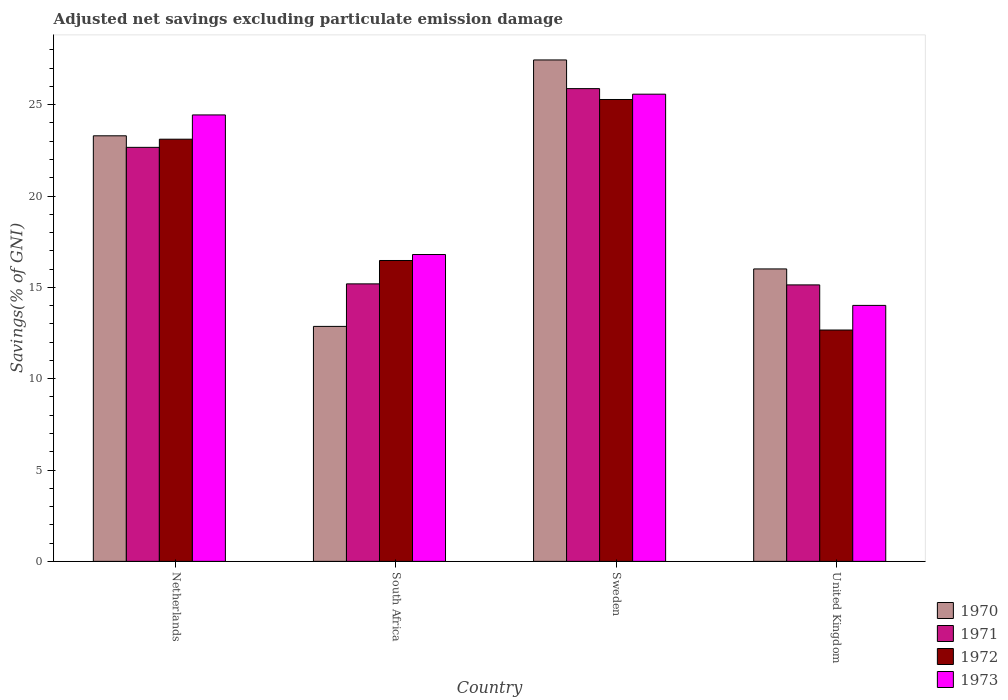How many different coloured bars are there?
Your answer should be very brief. 4. How many groups of bars are there?
Your response must be concise. 4. Are the number of bars on each tick of the X-axis equal?
Give a very brief answer. Yes. How many bars are there on the 4th tick from the right?
Make the answer very short. 4. What is the label of the 3rd group of bars from the left?
Your response must be concise. Sweden. What is the adjusted net savings in 1970 in Sweden?
Make the answer very short. 27.45. Across all countries, what is the maximum adjusted net savings in 1973?
Ensure brevity in your answer.  25.57. Across all countries, what is the minimum adjusted net savings in 1973?
Make the answer very short. 14.01. In which country was the adjusted net savings in 1970 minimum?
Provide a short and direct response. South Africa. What is the total adjusted net savings in 1972 in the graph?
Provide a short and direct response. 77.53. What is the difference between the adjusted net savings in 1971 in Netherlands and that in United Kingdom?
Ensure brevity in your answer.  7.53. What is the difference between the adjusted net savings in 1971 in Netherlands and the adjusted net savings in 1972 in United Kingdom?
Make the answer very short. 10. What is the average adjusted net savings in 1970 per country?
Ensure brevity in your answer.  19.9. What is the difference between the adjusted net savings of/in 1972 and adjusted net savings of/in 1973 in Netherlands?
Keep it short and to the point. -1.33. What is the ratio of the adjusted net savings in 1973 in South Africa to that in United Kingdom?
Make the answer very short. 1.2. Is the adjusted net savings in 1970 in Netherlands less than that in United Kingdom?
Provide a succinct answer. No. Is the difference between the adjusted net savings in 1972 in Netherlands and South Africa greater than the difference between the adjusted net savings in 1973 in Netherlands and South Africa?
Provide a succinct answer. No. What is the difference between the highest and the second highest adjusted net savings in 1970?
Your answer should be very brief. -11.44. What is the difference between the highest and the lowest adjusted net savings in 1971?
Ensure brevity in your answer.  10.74. In how many countries, is the adjusted net savings in 1972 greater than the average adjusted net savings in 1972 taken over all countries?
Your answer should be compact. 2. Is the sum of the adjusted net savings in 1972 in South Africa and United Kingdom greater than the maximum adjusted net savings in 1973 across all countries?
Your answer should be very brief. Yes. Is it the case that in every country, the sum of the adjusted net savings in 1973 and adjusted net savings in 1972 is greater than the sum of adjusted net savings in 1971 and adjusted net savings in 1970?
Ensure brevity in your answer.  No. What does the 3rd bar from the right in Sweden represents?
Your response must be concise. 1971. Is it the case that in every country, the sum of the adjusted net savings in 1971 and adjusted net savings in 1972 is greater than the adjusted net savings in 1973?
Your answer should be compact. Yes. What is the difference between two consecutive major ticks on the Y-axis?
Offer a terse response. 5. Does the graph contain any zero values?
Offer a very short reply. No. Does the graph contain grids?
Give a very brief answer. No. Where does the legend appear in the graph?
Offer a terse response. Bottom right. How many legend labels are there?
Your answer should be compact. 4. How are the legend labels stacked?
Offer a very short reply. Vertical. What is the title of the graph?
Give a very brief answer. Adjusted net savings excluding particulate emission damage. Does "1990" appear as one of the legend labels in the graph?
Offer a terse response. No. What is the label or title of the Y-axis?
Provide a short and direct response. Savings(% of GNI). What is the Savings(% of GNI) of 1970 in Netherlands?
Offer a very short reply. 23.3. What is the Savings(% of GNI) of 1971 in Netherlands?
Provide a succinct answer. 22.66. What is the Savings(% of GNI) of 1972 in Netherlands?
Offer a terse response. 23.11. What is the Savings(% of GNI) of 1973 in Netherlands?
Keep it short and to the point. 24.44. What is the Savings(% of GNI) in 1970 in South Africa?
Ensure brevity in your answer.  12.86. What is the Savings(% of GNI) in 1971 in South Africa?
Give a very brief answer. 15.19. What is the Savings(% of GNI) in 1972 in South Africa?
Provide a short and direct response. 16.47. What is the Savings(% of GNI) in 1973 in South Africa?
Your answer should be very brief. 16.8. What is the Savings(% of GNI) in 1970 in Sweden?
Provide a short and direct response. 27.45. What is the Savings(% of GNI) in 1971 in Sweden?
Your answer should be compact. 25.88. What is the Savings(% of GNI) of 1972 in Sweden?
Provide a succinct answer. 25.28. What is the Savings(% of GNI) of 1973 in Sweden?
Your answer should be very brief. 25.57. What is the Savings(% of GNI) of 1970 in United Kingdom?
Ensure brevity in your answer.  16.01. What is the Savings(% of GNI) of 1971 in United Kingdom?
Your response must be concise. 15.13. What is the Savings(% of GNI) in 1972 in United Kingdom?
Your answer should be compact. 12.66. What is the Savings(% of GNI) of 1973 in United Kingdom?
Provide a succinct answer. 14.01. Across all countries, what is the maximum Savings(% of GNI) in 1970?
Give a very brief answer. 27.45. Across all countries, what is the maximum Savings(% of GNI) of 1971?
Provide a short and direct response. 25.88. Across all countries, what is the maximum Savings(% of GNI) of 1972?
Provide a succinct answer. 25.28. Across all countries, what is the maximum Savings(% of GNI) in 1973?
Provide a succinct answer. 25.57. Across all countries, what is the minimum Savings(% of GNI) of 1970?
Your response must be concise. 12.86. Across all countries, what is the minimum Savings(% of GNI) in 1971?
Your answer should be compact. 15.13. Across all countries, what is the minimum Savings(% of GNI) in 1972?
Provide a short and direct response. 12.66. Across all countries, what is the minimum Savings(% of GNI) of 1973?
Make the answer very short. 14.01. What is the total Savings(% of GNI) in 1970 in the graph?
Make the answer very short. 79.61. What is the total Savings(% of GNI) in 1971 in the graph?
Offer a very short reply. 78.87. What is the total Savings(% of GNI) of 1972 in the graph?
Offer a terse response. 77.53. What is the total Savings(% of GNI) in 1973 in the graph?
Your answer should be compact. 80.82. What is the difference between the Savings(% of GNI) in 1970 in Netherlands and that in South Africa?
Give a very brief answer. 10.43. What is the difference between the Savings(% of GNI) of 1971 in Netherlands and that in South Africa?
Provide a succinct answer. 7.47. What is the difference between the Savings(% of GNI) of 1972 in Netherlands and that in South Africa?
Offer a terse response. 6.64. What is the difference between the Savings(% of GNI) in 1973 in Netherlands and that in South Africa?
Keep it short and to the point. 7.64. What is the difference between the Savings(% of GNI) in 1970 in Netherlands and that in Sweden?
Give a very brief answer. -4.15. What is the difference between the Savings(% of GNI) in 1971 in Netherlands and that in Sweden?
Keep it short and to the point. -3.21. What is the difference between the Savings(% of GNI) of 1972 in Netherlands and that in Sweden?
Offer a terse response. -2.17. What is the difference between the Savings(% of GNI) of 1973 in Netherlands and that in Sweden?
Keep it short and to the point. -1.14. What is the difference between the Savings(% of GNI) of 1970 in Netherlands and that in United Kingdom?
Offer a very short reply. 7.29. What is the difference between the Savings(% of GNI) of 1971 in Netherlands and that in United Kingdom?
Provide a short and direct response. 7.53. What is the difference between the Savings(% of GNI) in 1972 in Netherlands and that in United Kingdom?
Provide a short and direct response. 10.45. What is the difference between the Savings(% of GNI) of 1973 in Netherlands and that in United Kingdom?
Your response must be concise. 10.43. What is the difference between the Savings(% of GNI) in 1970 in South Africa and that in Sweden?
Make the answer very short. -14.59. What is the difference between the Savings(% of GNI) in 1971 in South Africa and that in Sweden?
Keep it short and to the point. -10.69. What is the difference between the Savings(% of GNI) in 1972 in South Africa and that in Sweden?
Your answer should be very brief. -8.81. What is the difference between the Savings(% of GNI) of 1973 in South Africa and that in Sweden?
Your answer should be compact. -8.78. What is the difference between the Savings(% of GNI) of 1970 in South Africa and that in United Kingdom?
Offer a very short reply. -3.15. What is the difference between the Savings(% of GNI) of 1971 in South Africa and that in United Kingdom?
Provide a short and direct response. 0.06. What is the difference between the Savings(% of GNI) in 1972 in South Africa and that in United Kingdom?
Offer a very short reply. 3.81. What is the difference between the Savings(% of GNI) in 1973 in South Africa and that in United Kingdom?
Keep it short and to the point. 2.78. What is the difference between the Savings(% of GNI) of 1970 in Sweden and that in United Kingdom?
Offer a very short reply. 11.44. What is the difference between the Savings(% of GNI) in 1971 in Sweden and that in United Kingdom?
Provide a succinct answer. 10.74. What is the difference between the Savings(% of GNI) of 1972 in Sweden and that in United Kingdom?
Provide a succinct answer. 12.62. What is the difference between the Savings(% of GNI) in 1973 in Sweden and that in United Kingdom?
Your response must be concise. 11.56. What is the difference between the Savings(% of GNI) of 1970 in Netherlands and the Savings(% of GNI) of 1971 in South Africa?
Your answer should be compact. 8.11. What is the difference between the Savings(% of GNI) in 1970 in Netherlands and the Savings(% of GNI) in 1972 in South Africa?
Ensure brevity in your answer.  6.83. What is the difference between the Savings(% of GNI) in 1970 in Netherlands and the Savings(% of GNI) in 1973 in South Africa?
Make the answer very short. 6.5. What is the difference between the Savings(% of GNI) in 1971 in Netherlands and the Savings(% of GNI) in 1972 in South Africa?
Make the answer very short. 6.19. What is the difference between the Savings(% of GNI) of 1971 in Netherlands and the Savings(% of GNI) of 1973 in South Africa?
Keep it short and to the point. 5.87. What is the difference between the Savings(% of GNI) of 1972 in Netherlands and the Savings(% of GNI) of 1973 in South Africa?
Offer a very short reply. 6.31. What is the difference between the Savings(% of GNI) in 1970 in Netherlands and the Savings(% of GNI) in 1971 in Sweden?
Offer a very short reply. -2.58. What is the difference between the Savings(% of GNI) of 1970 in Netherlands and the Savings(% of GNI) of 1972 in Sweden?
Your answer should be very brief. -1.99. What is the difference between the Savings(% of GNI) of 1970 in Netherlands and the Savings(% of GNI) of 1973 in Sweden?
Give a very brief answer. -2.28. What is the difference between the Savings(% of GNI) in 1971 in Netherlands and the Savings(% of GNI) in 1972 in Sweden?
Your answer should be very brief. -2.62. What is the difference between the Savings(% of GNI) in 1971 in Netherlands and the Savings(% of GNI) in 1973 in Sweden?
Provide a short and direct response. -2.91. What is the difference between the Savings(% of GNI) of 1972 in Netherlands and the Savings(% of GNI) of 1973 in Sweden?
Keep it short and to the point. -2.46. What is the difference between the Savings(% of GNI) of 1970 in Netherlands and the Savings(% of GNI) of 1971 in United Kingdom?
Ensure brevity in your answer.  8.16. What is the difference between the Savings(% of GNI) in 1970 in Netherlands and the Savings(% of GNI) in 1972 in United Kingdom?
Your answer should be compact. 10.63. What is the difference between the Savings(% of GNI) in 1970 in Netherlands and the Savings(% of GNI) in 1973 in United Kingdom?
Keep it short and to the point. 9.28. What is the difference between the Savings(% of GNI) in 1971 in Netherlands and the Savings(% of GNI) in 1972 in United Kingdom?
Provide a short and direct response. 10. What is the difference between the Savings(% of GNI) in 1971 in Netherlands and the Savings(% of GNI) in 1973 in United Kingdom?
Your response must be concise. 8.65. What is the difference between the Savings(% of GNI) in 1972 in Netherlands and the Savings(% of GNI) in 1973 in United Kingdom?
Offer a terse response. 9.1. What is the difference between the Savings(% of GNI) in 1970 in South Africa and the Savings(% of GNI) in 1971 in Sweden?
Your answer should be very brief. -13.02. What is the difference between the Savings(% of GNI) in 1970 in South Africa and the Savings(% of GNI) in 1972 in Sweden?
Make the answer very short. -12.42. What is the difference between the Savings(% of GNI) of 1970 in South Africa and the Savings(% of GNI) of 1973 in Sweden?
Ensure brevity in your answer.  -12.71. What is the difference between the Savings(% of GNI) of 1971 in South Africa and the Savings(% of GNI) of 1972 in Sweden?
Provide a short and direct response. -10.09. What is the difference between the Savings(% of GNI) in 1971 in South Africa and the Savings(% of GNI) in 1973 in Sweden?
Provide a short and direct response. -10.38. What is the difference between the Savings(% of GNI) in 1972 in South Africa and the Savings(% of GNI) in 1973 in Sweden?
Your response must be concise. -9.1. What is the difference between the Savings(% of GNI) in 1970 in South Africa and the Savings(% of GNI) in 1971 in United Kingdom?
Offer a terse response. -2.27. What is the difference between the Savings(% of GNI) of 1970 in South Africa and the Savings(% of GNI) of 1972 in United Kingdom?
Keep it short and to the point. 0.2. What is the difference between the Savings(% of GNI) of 1970 in South Africa and the Savings(% of GNI) of 1973 in United Kingdom?
Your response must be concise. -1.15. What is the difference between the Savings(% of GNI) of 1971 in South Africa and the Savings(% of GNI) of 1972 in United Kingdom?
Offer a very short reply. 2.53. What is the difference between the Savings(% of GNI) of 1971 in South Africa and the Savings(% of GNI) of 1973 in United Kingdom?
Give a very brief answer. 1.18. What is the difference between the Savings(% of GNI) in 1972 in South Africa and the Savings(% of GNI) in 1973 in United Kingdom?
Keep it short and to the point. 2.46. What is the difference between the Savings(% of GNI) in 1970 in Sweden and the Savings(% of GNI) in 1971 in United Kingdom?
Your response must be concise. 12.31. What is the difference between the Savings(% of GNI) in 1970 in Sweden and the Savings(% of GNI) in 1972 in United Kingdom?
Give a very brief answer. 14.78. What is the difference between the Savings(% of GNI) in 1970 in Sweden and the Savings(% of GNI) in 1973 in United Kingdom?
Ensure brevity in your answer.  13.44. What is the difference between the Savings(% of GNI) of 1971 in Sweden and the Savings(% of GNI) of 1972 in United Kingdom?
Your answer should be very brief. 13.21. What is the difference between the Savings(% of GNI) of 1971 in Sweden and the Savings(% of GNI) of 1973 in United Kingdom?
Offer a terse response. 11.87. What is the difference between the Savings(% of GNI) of 1972 in Sweden and the Savings(% of GNI) of 1973 in United Kingdom?
Keep it short and to the point. 11.27. What is the average Savings(% of GNI) of 1970 per country?
Offer a terse response. 19.9. What is the average Savings(% of GNI) of 1971 per country?
Provide a succinct answer. 19.72. What is the average Savings(% of GNI) in 1972 per country?
Your answer should be very brief. 19.38. What is the average Savings(% of GNI) of 1973 per country?
Provide a succinct answer. 20.21. What is the difference between the Savings(% of GNI) in 1970 and Savings(% of GNI) in 1971 in Netherlands?
Keep it short and to the point. 0.63. What is the difference between the Savings(% of GNI) in 1970 and Savings(% of GNI) in 1972 in Netherlands?
Keep it short and to the point. 0.19. What is the difference between the Savings(% of GNI) of 1970 and Savings(% of GNI) of 1973 in Netherlands?
Provide a short and direct response. -1.14. What is the difference between the Savings(% of GNI) in 1971 and Savings(% of GNI) in 1972 in Netherlands?
Keep it short and to the point. -0.45. What is the difference between the Savings(% of GNI) in 1971 and Savings(% of GNI) in 1973 in Netherlands?
Your response must be concise. -1.77. What is the difference between the Savings(% of GNI) in 1972 and Savings(% of GNI) in 1973 in Netherlands?
Provide a short and direct response. -1.33. What is the difference between the Savings(% of GNI) in 1970 and Savings(% of GNI) in 1971 in South Africa?
Provide a short and direct response. -2.33. What is the difference between the Savings(% of GNI) of 1970 and Savings(% of GNI) of 1972 in South Africa?
Offer a terse response. -3.61. What is the difference between the Savings(% of GNI) of 1970 and Savings(% of GNI) of 1973 in South Africa?
Ensure brevity in your answer.  -3.93. What is the difference between the Savings(% of GNI) in 1971 and Savings(% of GNI) in 1972 in South Africa?
Keep it short and to the point. -1.28. What is the difference between the Savings(% of GNI) in 1971 and Savings(% of GNI) in 1973 in South Africa?
Ensure brevity in your answer.  -1.61. What is the difference between the Savings(% of GNI) in 1972 and Savings(% of GNI) in 1973 in South Africa?
Provide a short and direct response. -0.33. What is the difference between the Savings(% of GNI) of 1970 and Savings(% of GNI) of 1971 in Sweden?
Provide a short and direct response. 1.57. What is the difference between the Savings(% of GNI) of 1970 and Savings(% of GNI) of 1972 in Sweden?
Provide a short and direct response. 2.16. What is the difference between the Savings(% of GNI) in 1970 and Savings(% of GNI) in 1973 in Sweden?
Keep it short and to the point. 1.87. What is the difference between the Savings(% of GNI) of 1971 and Savings(% of GNI) of 1972 in Sweden?
Keep it short and to the point. 0.59. What is the difference between the Savings(% of GNI) of 1971 and Savings(% of GNI) of 1973 in Sweden?
Provide a short and direct response. 0.3. What is the difference between the Savings(% of GNI) in 1972 and Savings(% of GNI) in 1973 in Sweden?
Make the answer very short. -0.29. What is the difference between the Savings(% of GNI) in 1970 and Savings(% of GNI) in 1971 in United Kingdom?
Make the answer very short. 0.87. What is the difference between the Savings(% of GNI) in 1970 and Savings(% of GNI) in 1972 in United Kingdom?
Offer a very short reply. 3.34. What is the difference between the Savings(% of GNI) of 1970 and Savings(% of GNI) of 1973 in United Kingdom?
Provide a short and direct response. 2. What is the difference between the Savings(% of GNI) in 1971 and Savings(% of GNI) in 1972 in United Kingdom?
Provide a short and direct response. 2.47. What is the difference between the Savings(% of GNI) of 1971 and Savings(% of GNI) of 1973 in United Kingdom?
Ensure brevity in your answer.  1.12. What is the difference between the Savings(% of GNI) of 1972 and Savings(% of GNI) of 1973 in United Kingdom?
Your response must be concise. -1.35. What is the ratio of the Savings(% of GNI) in 1970 in Netherlands to that in South Africa?
Keep it short and to the point. 1.81. What is the ratio of the Savings(% of GNI) in 1971 in Netherlands to that in South Africa?
Give a very brief answer. 1.49. What is the ratio of the Savings(% of GNI) in 1972 in Netherlands to that in South Africa?
Provide a short and direct response. 1.4. What is the ratio of the Savings(% of GNI) in 1973 in Netherlands to that in South Africa?
Offer a very short reply. 1.46. What is the ratio of the Savings(% of GNI) in 1970 in Netherlands to that in Sweden?
Your answer should be very brief. 0.85. What is the ratio of the Savings(% of GNI) in 1971 in Netherlands to that in Sweden?
Give a very brief answer. 0.88. What is the ratio of the Savings(% of GNI) in 1972 in Netherlands to that in Sweden?
Offer a very short reply. 0.91. What is the ratio of the Savings(% of GNI) in 1973 in Netherlands to that in Sweden?
Your answer should be compact. 0.96. What is the ratio of the Savings(% of GNI) in 1970 in Netherlands to that in United Kingdom?
Ensure brevity in your answer.  1.46. What is the ratio of the Savings(% of GNI) in 1971 in Netherlands to that in United Kingdom?
Give a very brief answer. 1.5. What is the ratio of the Savings(% of GNI) in 1972 in Netherlands to that in United Kingdom?
Your answer should be compact. 1.82. What is the ratio of the Savings(% of GNI) of 1973 in Netherlands to that in United Kingdom?
Your answer should be compact. 1.74. What is the ratio of the Savings(% of GNI) of 1970 in South Africa to that in Sweden?
Provide a short and direct response. 0.47. What is the ratio of the Savings(% of GNI) in 1971 in South Africa to that in Sweden?
Provide a succinct answer. 0.59. What is the ratio of the Savings(% of GNI) of 1972 in South Africa to that in Sweden?
Ensure brevity in your answer.  0.65. What is the ratio of the Savings(% of GNI) of 1973 in South Africa to that in Sweden?
Keep it short and to the point. 0.66. What is the ratio of the Savings(% of GNI) in 1970 in South Africa to that in United Kingdom?
Provide a succinct answer. 0.8. What is the ratio of the Savings(% of GNI) of 1972 in South Africa to that in United Kingdom?
Keep it short and to the point. 1.3. What is the ratio of the Savings(% of GNI) in 1973 in South Africa to that in United Kingdom?
Offer a very short reply. 1.2. What is the ratio of the Savings(% of GNI) in 1970 in Sweden to that in United Kingdom?
Provide a succinct answer. 1.71. What is the ratio of the Savings(% of GNI) of 1971 in Sweden to that in United Kingdom?
Your answer should be very brief. 1.71. What is the ratio of the Savings(% of GNI) in 1972 in Sweden to that in United Kingdom?
Your response must be concise. 2. What is the ratio of the Savings(% of GNI) in 1973 in Sweden to that in United Kingdom?
Provide a short and direct response. 1.83. What is the difference between the highest and the second highest Savings(% of GNI) in 1970?
Your answer should be compact. 4.15. What is the difference between the highest and the second highest Savings(% of GNI) of 1971?
Offer a terse response. 3.21. What is the difference between the highest and the second highest Savings(% of GNI) in 1972?
Offer a terse response. 2.17. What is the difference between the highest and the second highest Savings(% of GNI) of 1973?
Keep it short and to the point. 1.14. What is the difference between the highest and the lowest Savings(% of GNI) in 1970?
Offer a very short reply. 14.59. What is the difference between the highest and the lowest Savings(% of GNI) of 1971?
Make the answer very short. 10.74. What is the difference between the highest and the lowest Savings(% of GNI) in 1972?
Provide a short and direct response. 12.62. What is the difference between the highest and the lowest Savings(% of GNI) in 1973?
Provide a succinct answer. 11.56. 